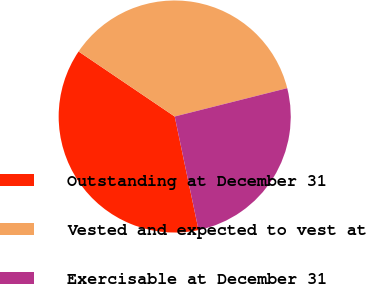<chart> <loc_0><loc_0><loc_500><loc_500><pie_chart><fcel>Outstanding at December 31<fcel>Vested and expected to vest at<fcel>Exercisable at December 31<nl><fcel>37.76%<fcel>36.6%<fcel>25.63%<nl></chart> 